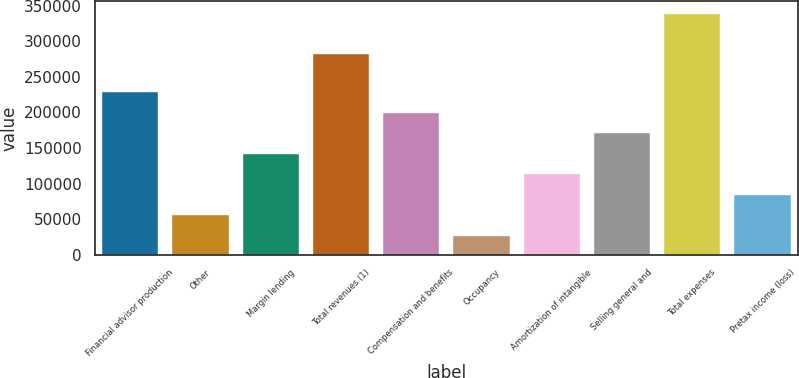Convert chart to OTSL. <chart><loc_0><loc_0><loc_500><loc_500><bar_chart><fcel>Financial advisor production<fcel>Other<fcel>Margin lending<fcel>Total revenues (1)<fcel>Compensation and benefits<fcel>Occupancy<fcel>Amortization of intangible<fcel>Selling general and<fcel>Total expenses<fcel>Pretax income (loss)<nl><fcel>227994<fcel>55687.7<fcel>141841<fcel>281312<fcel>199276<fcel>26970<fcel>113123<fcel>170558<fcel>338747<fcel>84405.4<nl></chart> 